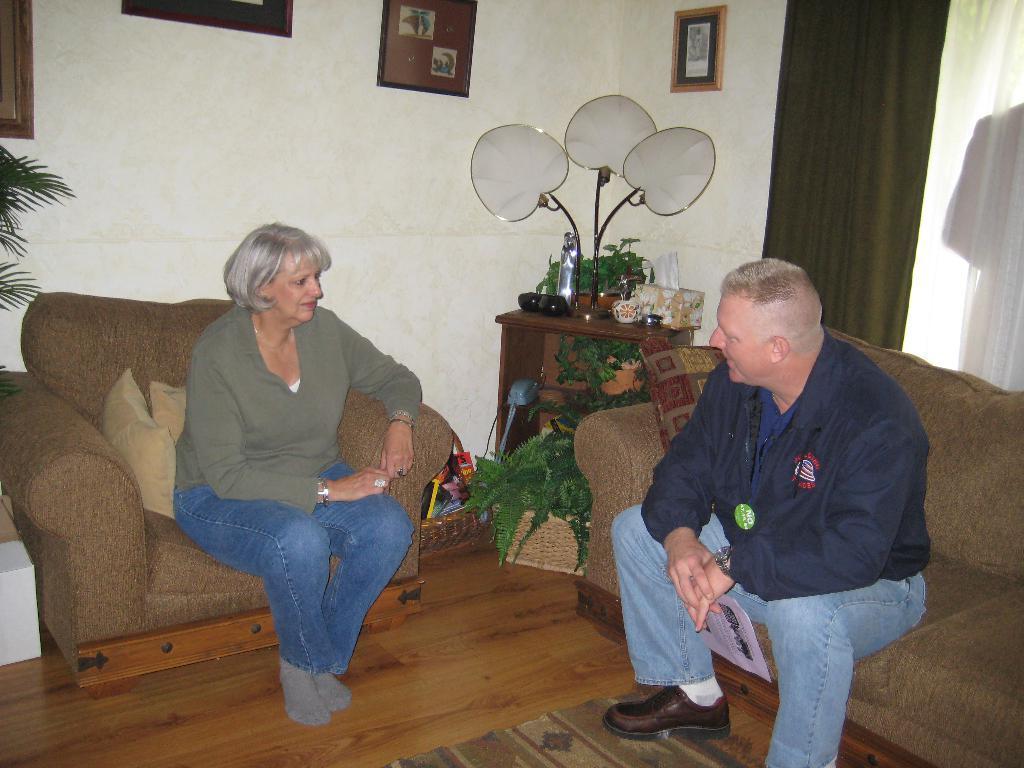In one or two sentences, can you explain what this image depicts? As we can see in the image there is a wall, photo frame and sofas and there are two people. 